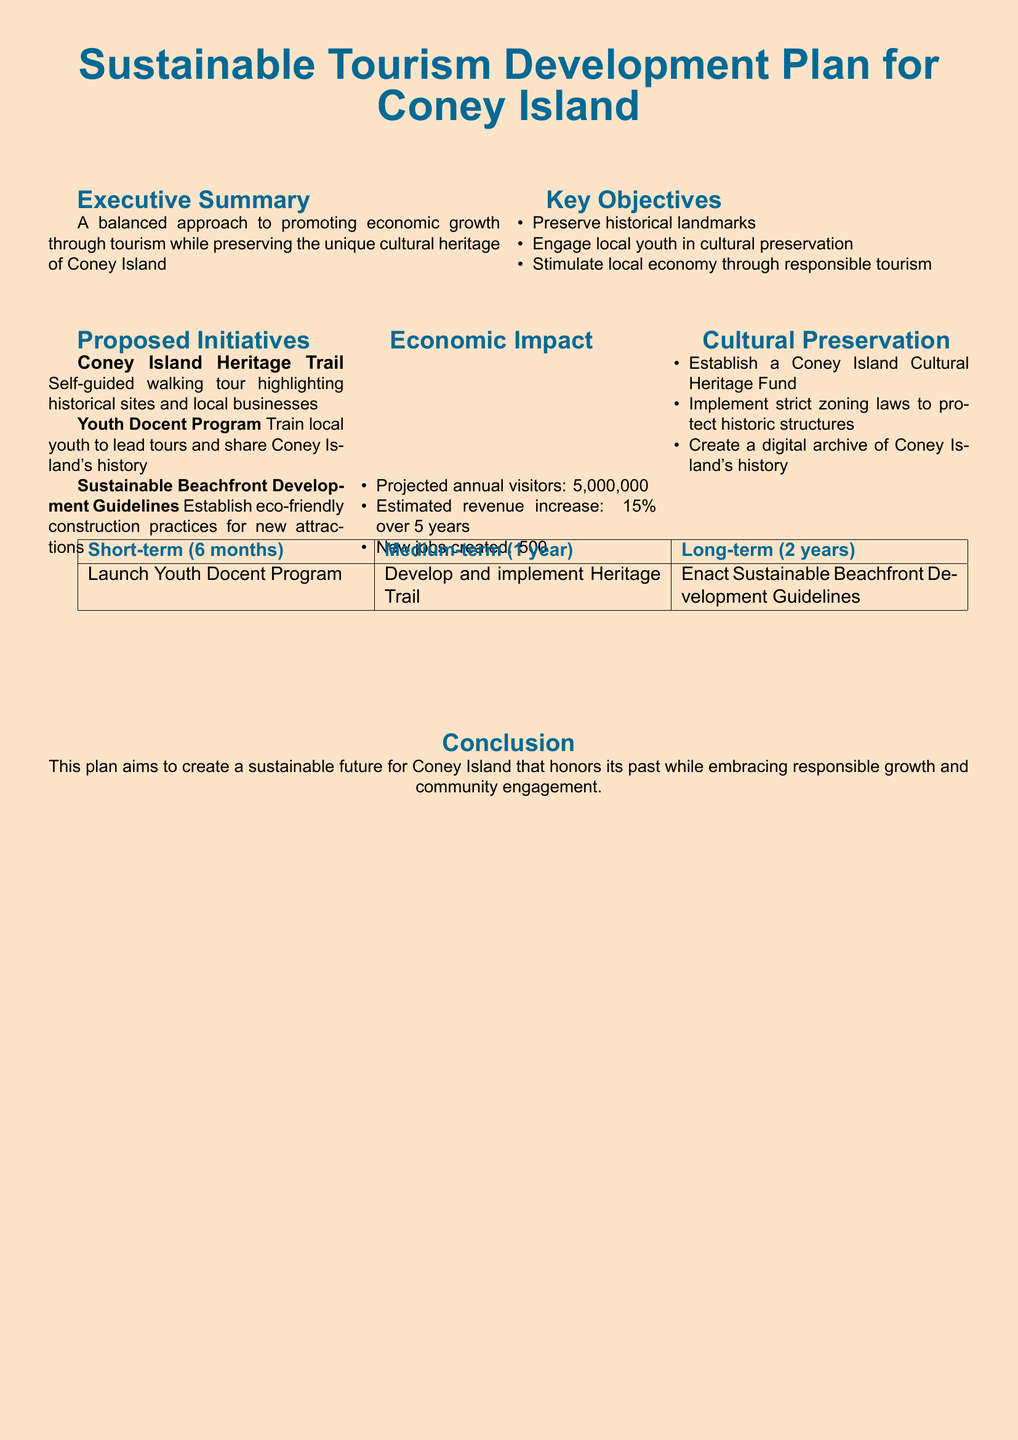What are the key objectives of the plan? The key objectives are listed in a bulleted format, which includes preserving historical landmarks, engaging local youth in cultural preservation, and stimulating the local economy through responsible tourism.
Answer: Preserve historical landmarks, engage local youth in cultural preservation, stimulate local economy through responsible tourism How many projected annual visitors are expected? The document states the projected annual visitors as a specific number, which is mentioned under the Economic Impact section.
Answer: 5,000,000 What initiative aims to train local youth? The Youth Docent Program is specifically mentioned as the initiative aimed at training local youth to lead tours.
Answer: Youth Docent Program What is the estimated revenue increase over 5 years? The document provides a numerical estimate in the Economic Impact section, which reflects the expected growth in revenue.
Answer: 15% What is the purpose of the Coney Island Cultural Heritage Fund? The establishment of the fund is mentioned in the Cultural Preservation section as a means to support cultural heritage efforts.
Answer: Establish a Coney Island Cultural Heritage Fund Which initiative is focused on creating a self-guided walking tour? The Coney Island Heritage Trail initiative is explicitly described as a walking tour that highlights historical sites and local businesses.
Answer: Coney Island Heritage Trail What are the short-term goals within six months? The short-term goals are specified in a table format and focus on the launch of the Youth Docent Program.
Answer: Launch Youth Docent Program What long-term guideline is proposed for sustainable development? The document mentions the enactment of Sustainable Beachfront Development Guidelines as a long-term initiative.
Answer: Enact Sustainable Beachfront Development Guidelines 